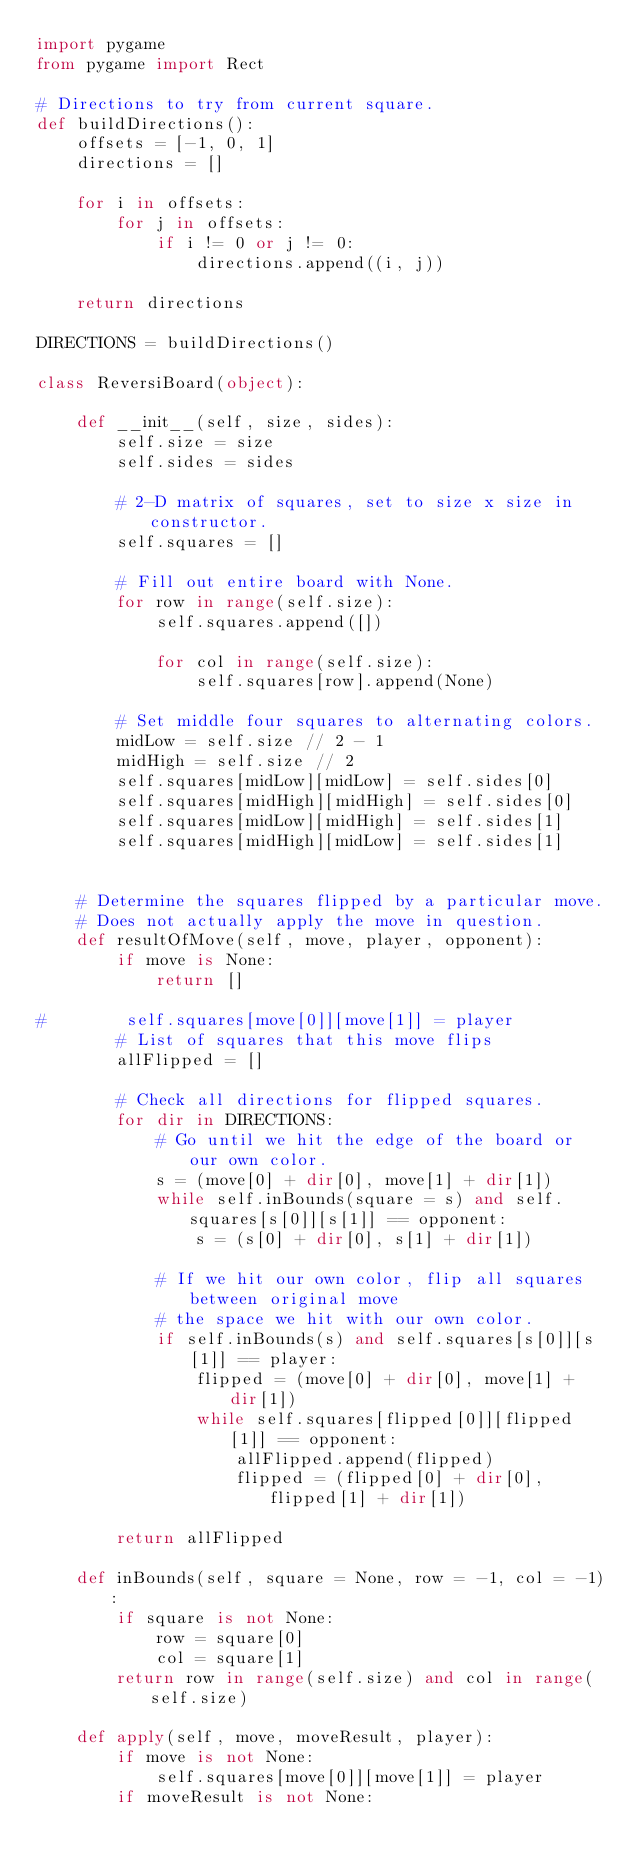<code> <loc_0><loc_0><loc_500><loc_500><_Python_>import pygame
from pygame import Rect

# Directions to try from current square.
def buildDirections():
    offsets = [-1, 0, 1]
    directions = []

    for i in offsets:
        for j in offsets:
            if i != 0 or j != 0:
                directions.append((i, j))

    return directions

DIRECTIONS = buildDirections()

class ReversiBoard(object):

    def __init__(self, size, sides):
        self.size = size
        self.sides = sides

        # 2-D matrix of squares, set to size x size in constructor.
        self.squares = []

        # Fill out entire board with None.
        for row in range(self.size):
            self.squares.append([])

            for col in range(self.size):
                self.squares[row].append(None)

        # Set middle four squares to alternating colors.
        midLow = self.size // 2 - 1
        midHigh = self.size // 2
        self.squares[midLow][midLow] = self.sides[0]
        self.squares[midHigh][midHigh] = self.sides[0]
        self.squares[midLow][midHigh] = self.sides[1]
        self.squares[midHigh][midLow] = self.sides[1]


    # Determine the squares flipped by a particular move.
    # Does not actually apply the move in question.
    def resultOfMove(self, move, player, opponent):
        if move is None:
            return []

#        self.squares[move[0]][move[1]] = player
        # List of squares that this move flips
        allFlipped = []

        # Check all directions for flipped squares.
        for dir in DIRECTIONS:
            # Go until we hit the edge of the board or our own color.
            s = (move[0] + dir[0], move[1] + dir[1])
            while self.inBounds(square = s) and self.squares[s[0]][s[1]] == opponent:
                s = (s[0] + dir[0], s[1] + dir[1])

            # If we hit our own color, flip all squares between original move
            # the space we hit with our own color.
            if self.inBounds(s) and self.squares[s[0]][s[1]] == player:
                flipped = (move[0] + dir[0], move[1] + dir[1])
                while self.squares[flipped[0]][flipped[1]] == opponent:
                    allFlipped.append(flipped)
                    flipped = (flipped[0] + dir[0], flipped[1] + dir[1])

        return allFlipped

    def inBounds(self, square = None, row = -1, col = -1):
        if square is not None:
            row = square[0]
            col = square[1]
        return row in range(self.size) and col in range(self.size)

    def apply(self, move, moveResult, player):
        if move is not None:
            self.squares[move[0]][move[1]] = player
        if moveResult is not None:</code> 